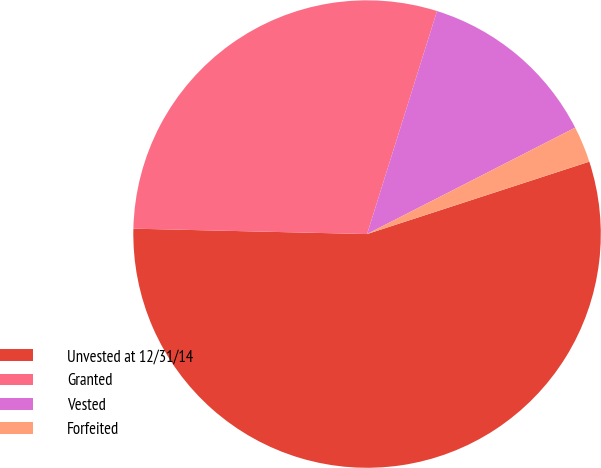Convert chart. <chart><loc_0><loc_0><loc_500><loc_500><pie_chart><fcel>Unvested at 12/31/14<fcel>Granted<fcel>Vested<fcel>Forfeited<nl><fcel>55.38%<fcel>29.47%<fcel>12.64%<fcel>2.51%<nl></chart> 